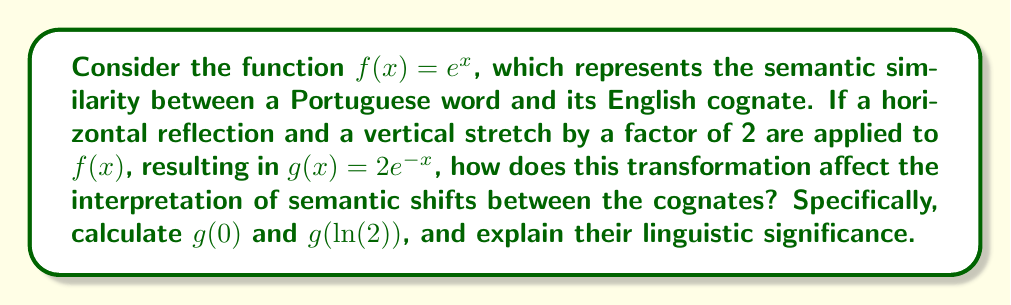Show me your answer to this math problem. 1) First, let's understand the transformations applied to $f(x) = e^x$ to get $g(x) = 2e^{-x}$:
   - Horizontal reflection: $x$ becomes $-x$
   - Vertical stretch by a factor of 2: multiply the function by 2

2) Now, let's calculate $g(0)$:
   $$g(0) = 2e^{-0} = 2e^0 = 2 \cdot 1 = 2$$

3) Next, let's calculate $g(\ln(2))$:
   $$g(\ln(2)) = 2e^{-\ln(2)} = 2 \cdot \frac{1}{e^{\ln(2)}} = 2 \cdot \frac{1}{2} = 1$$

4) Linguistic interpretation:
   - $g(0) = 2$ indicates that when there's no semantic shift (x = 0), the similarity is doubled compared to the original function. This could represent an intensification of meaning in cognates.
   - $g(\ln(2)) = 1$ shows that for a specific positive semantic shift $(\ln(2))$, the similarity returns to the baseline (1). This might represent a case where a semantic change brings the cognate back to its original meaning.

5) The horizontal reflection in $g(x)$ means that positive x-values (rightward shifts) now decrease similarity, while negative x-values (leftward shifts) increase it. This could model how semantic shifts in opposite directions affect cognate relationships differently in Portuguese and English.

6) The vertical stretch emphasizes these changes, making the differences in similarity more pronounced. This could represent a heightened sensitivity to semantic shifts in the comparison between Portuguese and English cognates.
Answer: $g(0) = 2$, $g(\ln(2)) = 1$; reflects intensified similarity at no shift and return to baseline at specific positive shift, with amplified sensitivity to semantic changes. 